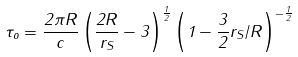Convert formula to latex. <formula><loc_0><loc_0><loc_500><loc_500>\tau _ { o } = \frac { 2 \pi R } { c } \left ( \frac { 2 R } { r _ { S } } - 3 \right ) ^ { \frac { 1 } { 2 } } \left ( 1 - \frac { 3 } { 2 } r _ { S } / R \right ) ^ { - \frac { 1 } { 2 } }</formula> 